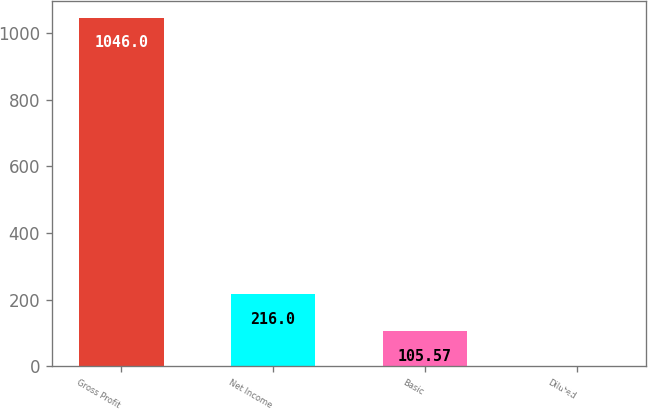Convert chart to OTSL. <chart><loc_0><loc_0><loc_500><loc_500><bar_chart><fcel>Gross Profit<fcel>Net Income<fcel>Basic<fcel>Diluted<nl><fcel>1046<fcel>216<fcel>105.57<fcel>1.08<nl></chart> 